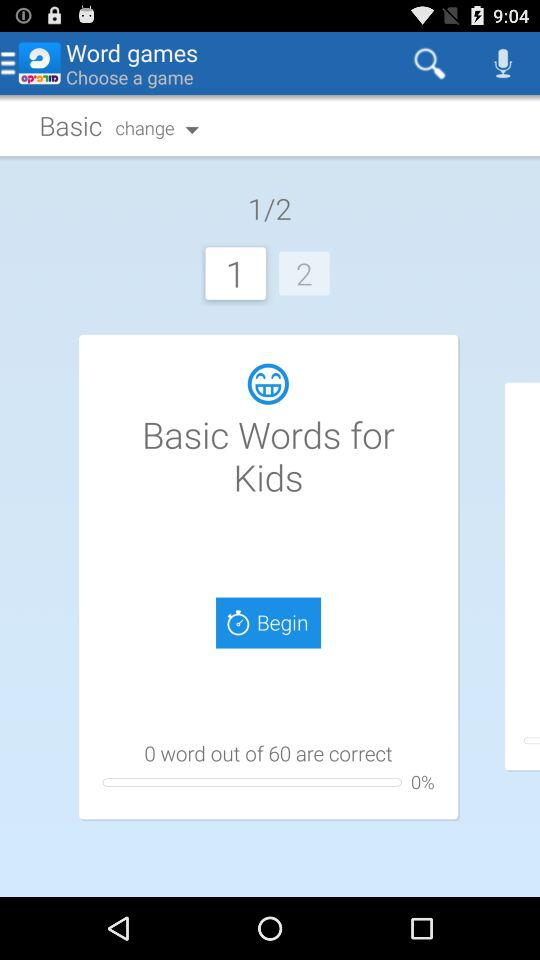What is the percentage of correct words? The percentage is 0%. 